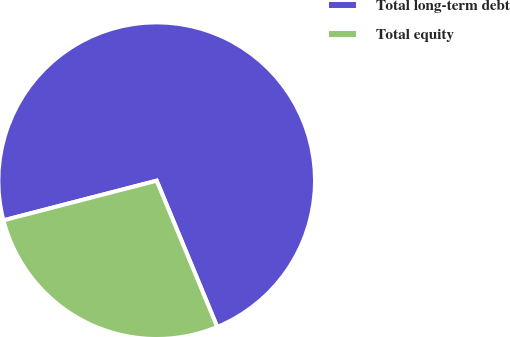Convert chart. <chart><loc_0><loc_0><loc_500><loc_500><pie_chart><fcel>Total long-term debt<fcel>Total equity<nl><fcel>72.78%<fcel>27.22%<nl></chart> 